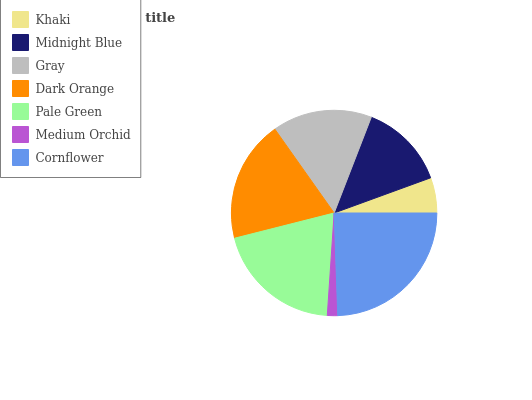Is Medium Orchid the minimum?
Answer yes or no. Yes. Is Cornflower the maximum?
Answer yes or no. Yes. Is Midnight Blue the minimum?
Answer yes or no. No. Is Midnight Blue the maximum?
Answer yes or no. No. Is Midnight Blue greater than Khaki?
Answer yes or no. Yes. Is Khaki less than Midnight Blue?
Answer yes or no. Yes. Is Khaki greater than Midnight Blue?
Answer yes or no. No. Is Midnight Blue less than Khaki?
Answer yes or no. No. Is Gray the high median?
Answer yes or no. Yes. Is Gray the low median?
Answer yes or no. Yes. Is Pale Green the high median?
Answer yes or no. No. Is Khaki the low median?
Answer yes or no. No. 